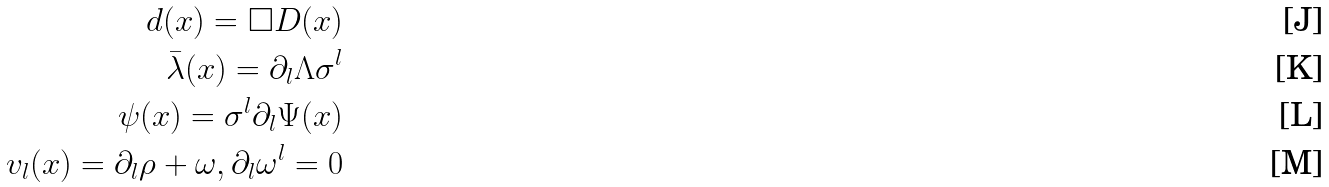<formula> <loc_0><loc_0><loc_500><loc_500>d ( x ) = \square D ( x ) \\ \bar { \lambda } ( x ) = \partial _ { l } \Lambda \sigma ^ { l } \\ \psi ( x ) = \sigma ^ { l } \partial _ { l } \Psi ( x ) \\ v _ { l } ( x ) = \partial _ { l } \rho + \omega , \partial _ { l } \omega ^ { l } = 0</formula> 